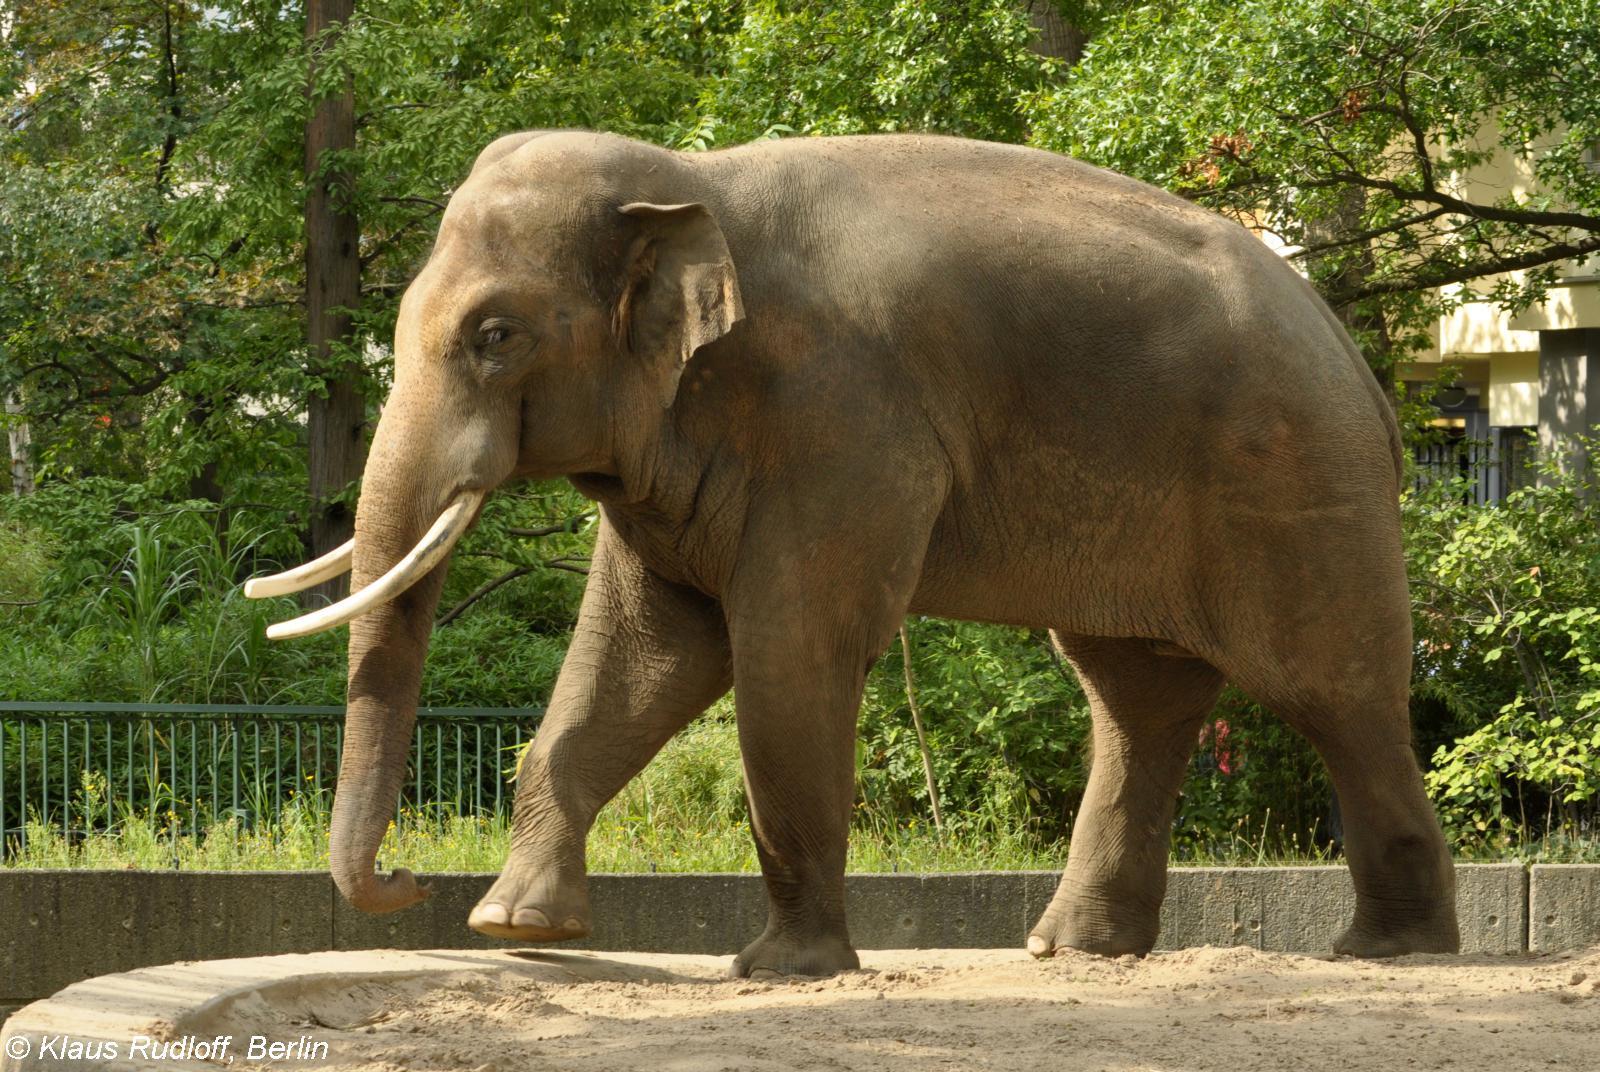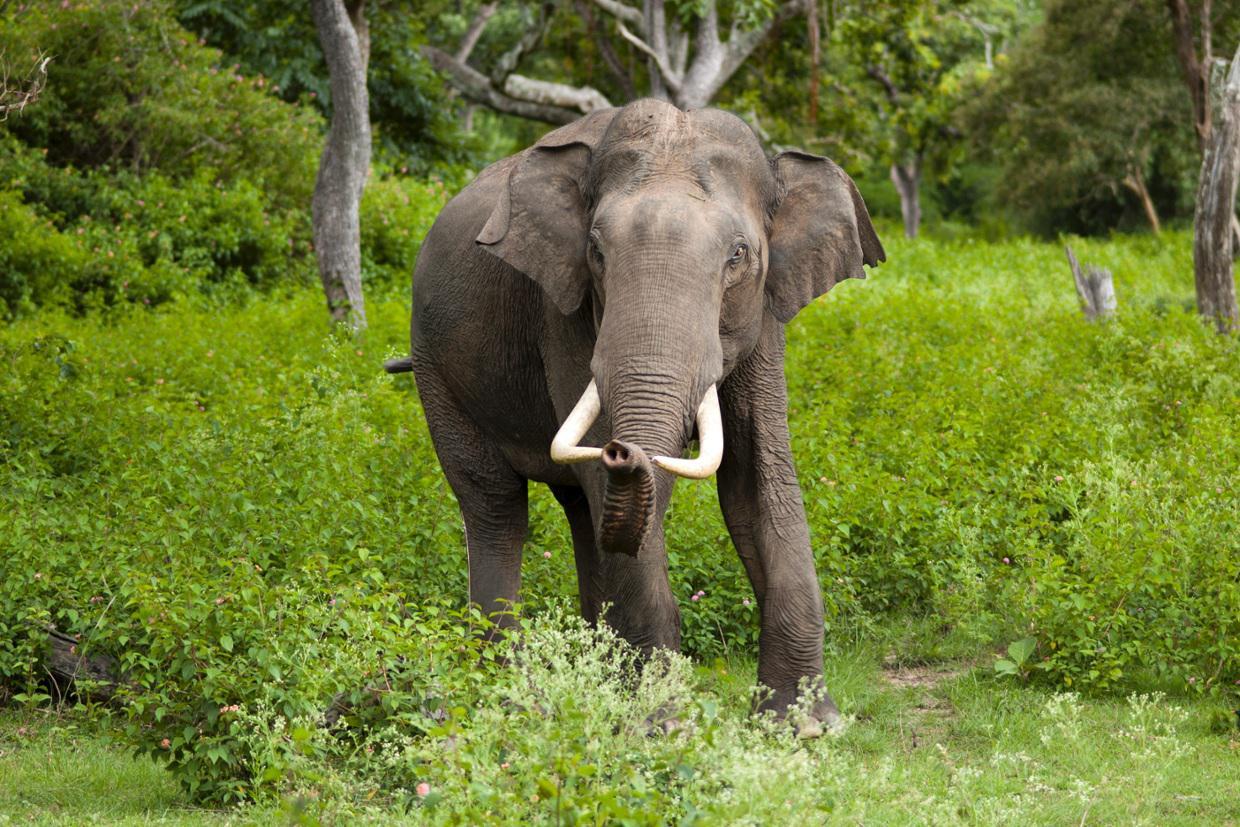The first image is the image on the left, the second image is the image on the right. Examine the images to the left and right. Is the description "All elephants have ivory tusks." accurate? Answer yes or no. Yes. 